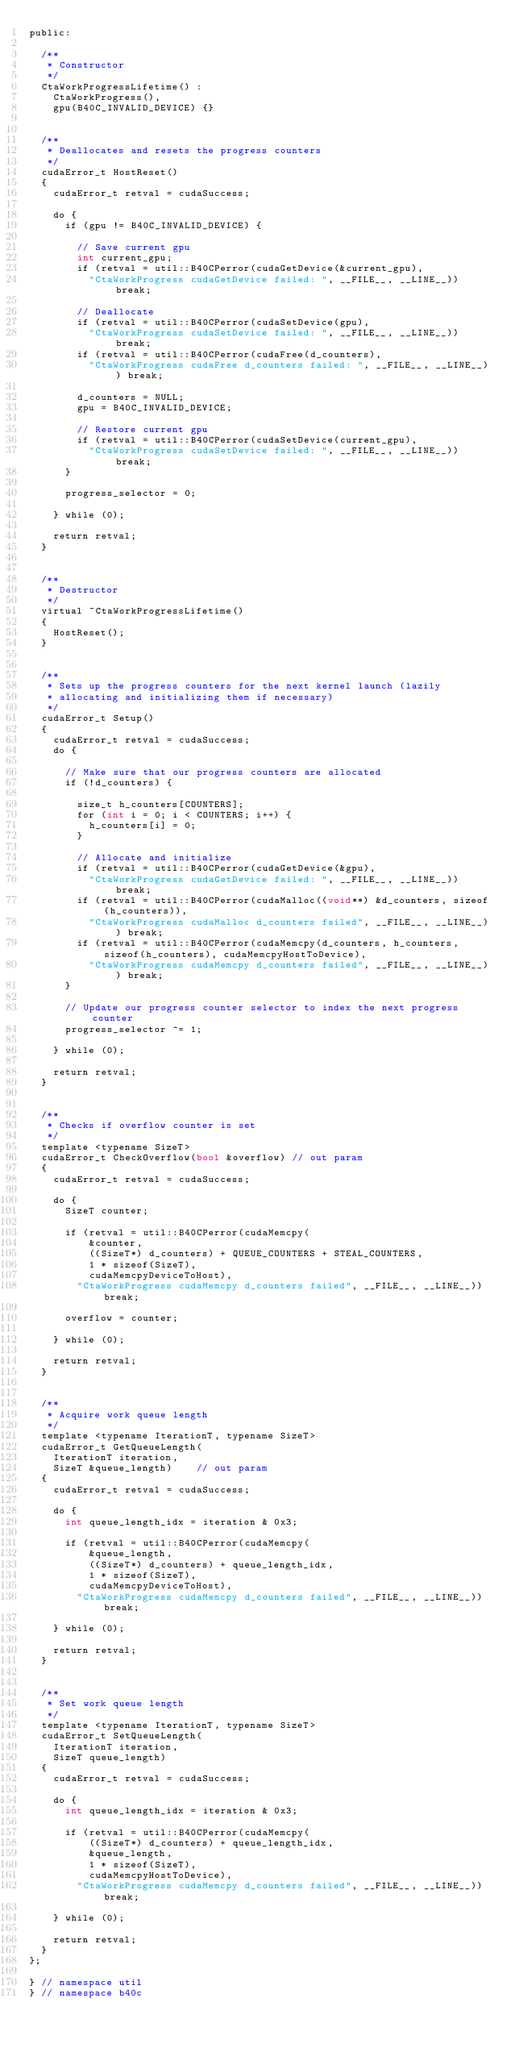Convert code to text. <code><loc_0><loc_0><loc_500><loc_500><_Cuda_>public:

	/**
	 * Constructor
	 */
	CtaWorkProgressLifetime() :
		CtaWorkProgress(),
		gpu(B40C_INVALID_DEVICE) {}


	/**
	 * Deallocates and resets the progress counters
	 */
	cudaError_t HostReset()
	{
		cudaError_t retval = cudaSuccess;

		do {
			if (gpu != B40C_INVALID_DEVICE) {

				// Save current gpu
				int current_gpu;
				if (retval = util::B40CPerror(cudaGetDevice(&current_gpu),
					"CtaWorkProgress cudaGetDevice failed: ", __FILE__, __LINE__)) break;

				// Deallocate
				if (retval = util::B40CPerror(cudaSetDevice(gpu),
					"CtaWorkProgress cudaSetDevice failed: ", __FILE__, __LINE__)) break;
				if (retval = util::B40CPerror(cudaFree(d_counters),
					"CtaWorkProgress cudaFree d_counters failed: ", __FILE__, __LINE__)) break;

				d_counters = NULL;
				gpu = B40C_INVALID_DEVICE;

				// Restore current gpu
				if (retval = util::B40CPerror(cudaSetDevice(current_gpu),
					"CtaWorkProgress cudaSetDevice failed: ", __FILE__, __LINE__)) break;
			}

			progress_selector = 0;

		} while (0);

		return retval;
	}


	/**
	 * Destructor
	 */
	virtual ~CtaWorkProgressLifetime()
	{
		HostReset();
	}


	/**
	 * Sets up the progress counters for the next kernel launch (lazily
	 * allocating and initializing them if necessary)
	 */
	cudaError_t Setup()
	{
		cudaError_t retval = cudaSuccess;
		do {

			// Make sure that our progress counters are allocated
			if (!d_counters) {

				size_t h_counters[COUNTERS];
				for (int i = 0; i < COUNTERS; i++) {
					h_counters[i] = 0;
				}

				// Allocate and initialize
				if (retval = util::B40CPerror(cudaGetDevice(&gpu),
					"CtaWorkProgress cudaGetDevice failed: ", __FILE__, __LINE__)) break;
				if (retval = util::B40CPerror(cudaMalloc((void**) &d_counters, sizeof(h_counters)),
					"CtaWorkProgress cudaMalloc d_counters failed", __FILE__, __LINE__)) break;
				if (retval = util::B40CPerror(cudaMemcpy(d_counters, h_counters, sizeof(h_counters), cudaMemcpyHostToDevice),
					"CtaWorkProgress cudaMemcpy d_counters failed", __FILE__, __LINE__)) break;
			}

			// Update our progress counter selector to index the next progress counter
			progress_selector ^= 1;

		} while (0);

		return retval;
	}


	/**
	 * Checks if overflow counter is set
	 */
	template <typename SizeT>
	cudaError_t CheckOverflow(bool &overflow)	// out param
	{
		cudaError_t retval = cudaSuccess;

		do {
			SizeT counter;

			if (retval = util::B40CPerror(cudaMemcpy(
					&counter,
					((SizeT*) d_counters) + QUEUE_COUNTERS + STEAL_COUNTERS,
					1 * sizeof(SizeT),
					cudaMemcpyDeviceToHost),
				"CtaWorkProgress cudaMemcpy d_counters failed", __FILE__, __LINE__)) break;

			overflow = counter;

		} while (0);

		return retval;
	}


	/**
	 * Acquire work queue length
	 */
	template <typename IterationT, typename SizeT>
	cudaError_t GetQueueLength(
		IterationT iteration,
		SizeT &queue_length)		// out param
	{
		cudaError_t retval = cudaSuccess;

		do {
			int queue_length_idx = iteration & 0x3;

			if (retval = util::B40CPerror(cudaMemcpy(
					&queue_length,
					((SizeT*) d_counters) + queue_length_idx,
					1 * sizeof(SizeT),
					cudaMemcpyDeviceToHost),
				"CtaWorkProgress cudaMemcpy d_counters failed", __FILE__, __LINE__)) break;

		} while (0);

		return retval;
	}


	/**
	 * Set work queue length
	 */
	template <typename IterationT, typename SizeT>
	cudaError_t SetQueueLength(
		IterationT iteration,
		SizeT queue_length)
	{
		cudaError_t retval = cudaSuccess;

		do {
			int queue_length_idx = iteration & 0x3;

			if (retval = util::B40CPerror(cudaMemcpy(
					((SizeT*) d_counters) + queue_length_idx,
					&queue_length,
					1 * sizeof(SizeT),
					cudaMemcpyHostToDevice),
				"CtaWorkProgress cudaMemcpy d_counters failed", __FILE__, __LINE__)) break;

		} while (0);

		return retval;
	}
};

} // namespace util
} // namespace b40c

</code> 